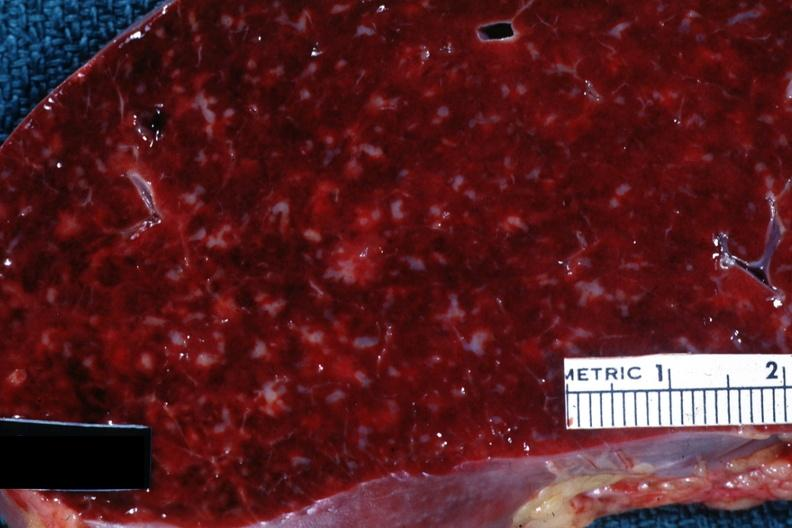s feet present?
Answer the question using a single word or phrase. No 